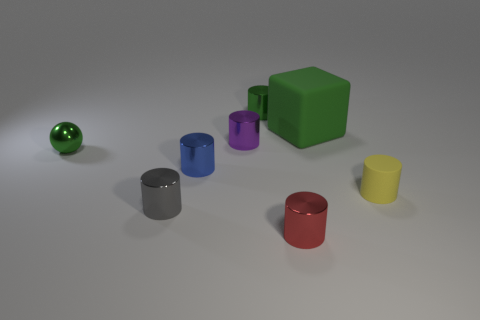Subtract all gray metal cylinders. How many cylinders are left? 5 Subtract all green cylinders. How many cylinders are left? 5 Subtract 2 cylinders. How many cylinders are left? 4 Subtract all green cylinders. Subtract all blue cubes. How many cylinders are left? 5 Add 1 large green blocks. How many objects exist? 9 Subtract all balls. How many objects are left? 7 Add 5 tiny yellow rubber objects. How many tiny yellow rubber objects are left? 6 Add 3 green matte cubes. How many green matte cubes exist? 4 Subtract 0 purple spheres. How many objects are left? 8 Subtract all large green matte balls. Subtract all spheres. How many objects are left? 7 